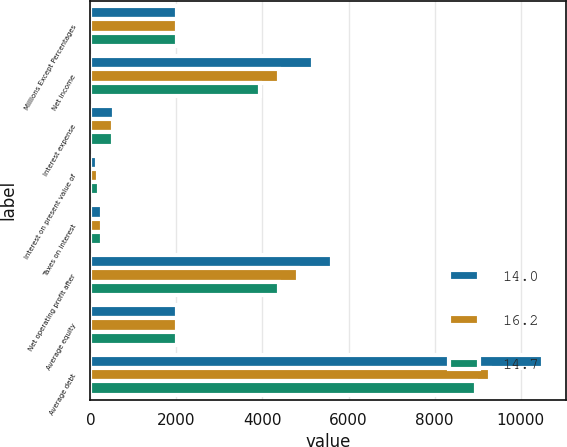Convert chart. <chart><loc_0><loc_0><loc_500><loc_500><stacked_bar_chart><ecel><fcel>Millions Except Percentages<fcel>Net income<fcel>Interest expense<fcel>Interest on present value of<fcel>Taxes on interest<fcel>Net operating profit after<fcel>Average equity<fcel>Average debt<nl><fcel>14<fcel>2014<fcel>5180<fcel>561<fcel>158<fcel>273<fcel>5626<fcel>2013<fcel>10529<nl><fcel>16.2<fcel>2013<fcel>4388<fcel>526<fcel>175<fcel>264<fcel>4825<fcel>2013<fcel>9287<nl><fcel>14.7<fcel>2012<fcel>3943<fcel>535<fcel>190<fcel>273<fcel>4395<fcel>2013<fcel>8952<nl></chart> 